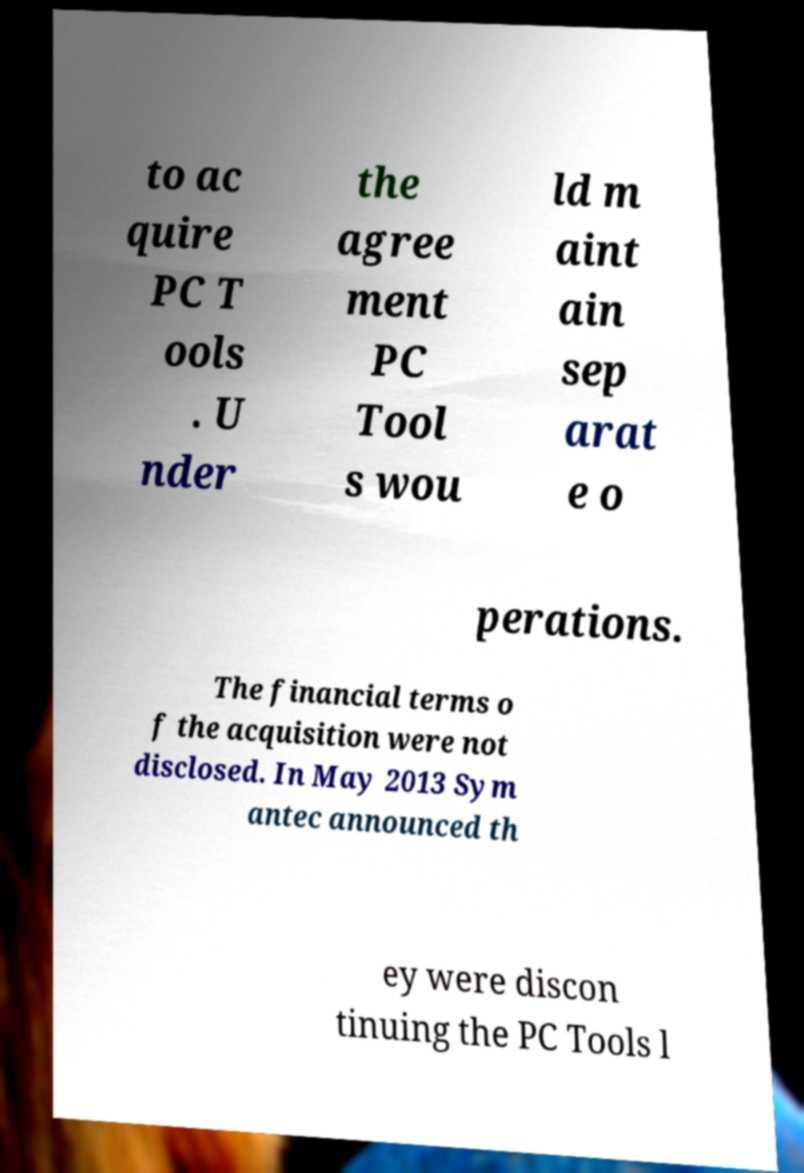Can you accurately transcribe the text from the provided image for me? to ac quire PC T ools . U nder the agree ment PC Tool s wou ld m aint ain sep arat e o perations. The financial terms o f the acquisition were not disclosed. In May 2013 Sym antec announced th ey were discon tinuing the PC Tools l 